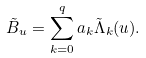<formula> <loc_0><loc_0><loc_500><loc_500>\tilde { B } _ { u } = \sum _ { k = 0 } ^ { q } a _ { k } \tilde { \Lambda } _ { k } ( u ) .</formula> 